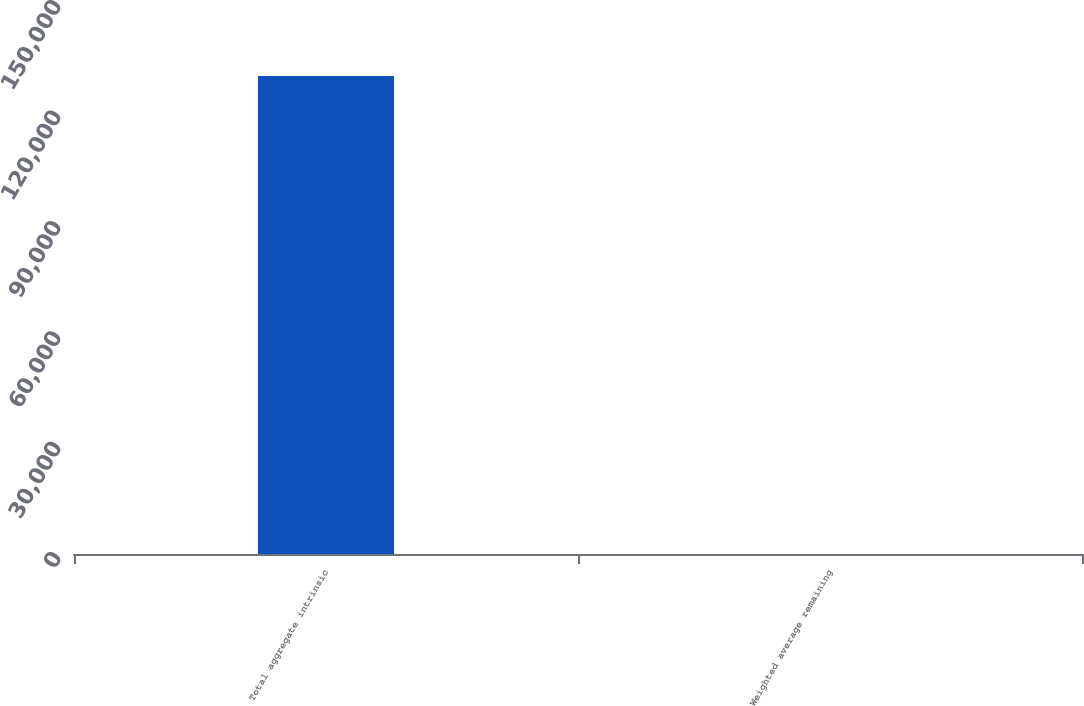Convert chart to OTSL. <chart><loc_0><loc_0><loc_500><loc_500><bar_chart><fcel>Total aggregate intrinsic<fcel>Weighted average remaining<nl><fcel>129880<fcel>1.3<nl></chart> 